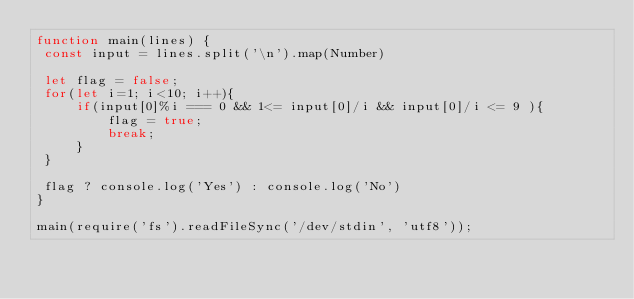<code> <loc_0><loc_0><loc_500><loc_500><_JavaScript_>function main(lines) {
 const input = lines.split('\n').map(Number)
 
 let flag = false;
 for(let i=1; i<10; i++){
     if(input[0]%i === 0 && 1<= input[0]/i && input[0]/i <= 9 ){
         flag = true;
         break;
     }
 }
 
 flag ? console.log('Yes') : console.log('No')
}

main(require('fs').readFileSync('/dev/stdin', 'utf8'));
</code> 